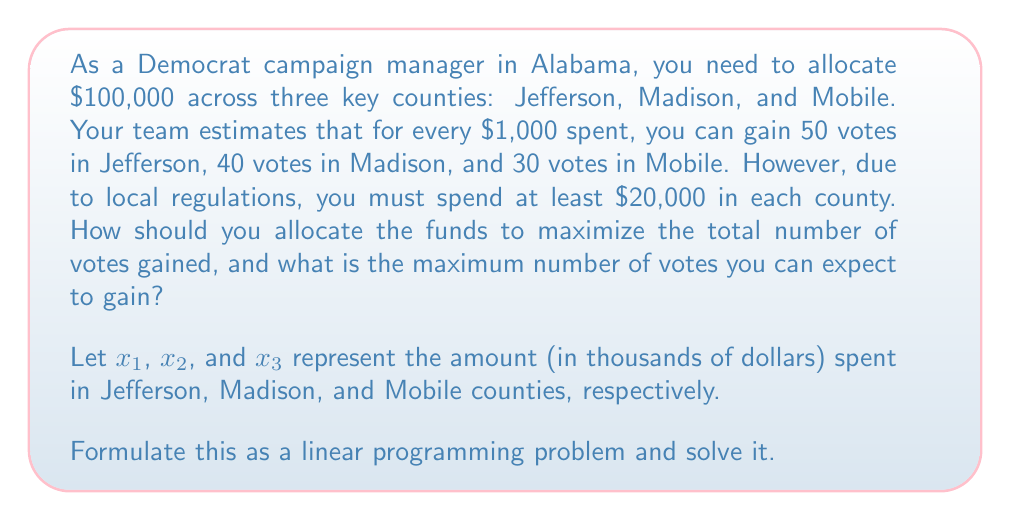What is the answer to this math problem? To solve this problem, we'll follow these steps:

1. Formulate the linear programming problem:

   Objective function: Maximize $Z = 50x_1 + 40x_2 + 30x_3$

   Subject to constraints:
   $$x_1 + x_2 + x_3 \leq 100$$ (total budget constraint)
   $$x_1 \geq 20, x_2 \geq 20, x_3 \geq 20$$ (minimum spending constraints)
   $$x_1, x_2, x_3 \geq 0$$ (non-negativity constraints)

2. Observe that the optimal solution will use the entire budget, so we can change the inequality to an equality:
   $$x_1 + x_2 + x_3 = 100$$

3. Since Jefferson County (x_1) has the highest return on investment, we should allocate as much as possible there after meeting the minimum requirements for all counties.

4. Allocate the minimum to Madison and Mobile:
   $x_2 = 20$ and $x_3 = 20$

5. Calculate the remaining amount for Jefferson:
   $x_1 = 100 - 20 - 20 = 60$

6. Check if this solution satisfies all constraints:
   $x_1 = 60 \geq 20$, $x_2 = 20 \geq 20$, $x_3 = 20 \geq 20$
   $60 + 20 + 20 = 100$ (budget constraint satisfied)

7. Calculate the maximum number of votes gained:
   $Z = 50(60) + 40(20) + 30(20) = 3000 + 800 + 600 = 4400$

Therefore, the optimal allocation is $60,000 to Jefferson County, $20,000 to Madison County, and $20,000 to Mobile County, resulting in a maximum of 4,400 votes gained.
Answer: Allocate $60,000 to Jefferson, $20,000 to Madison, $20,000 to Mobile; 4,400 votes gained. 